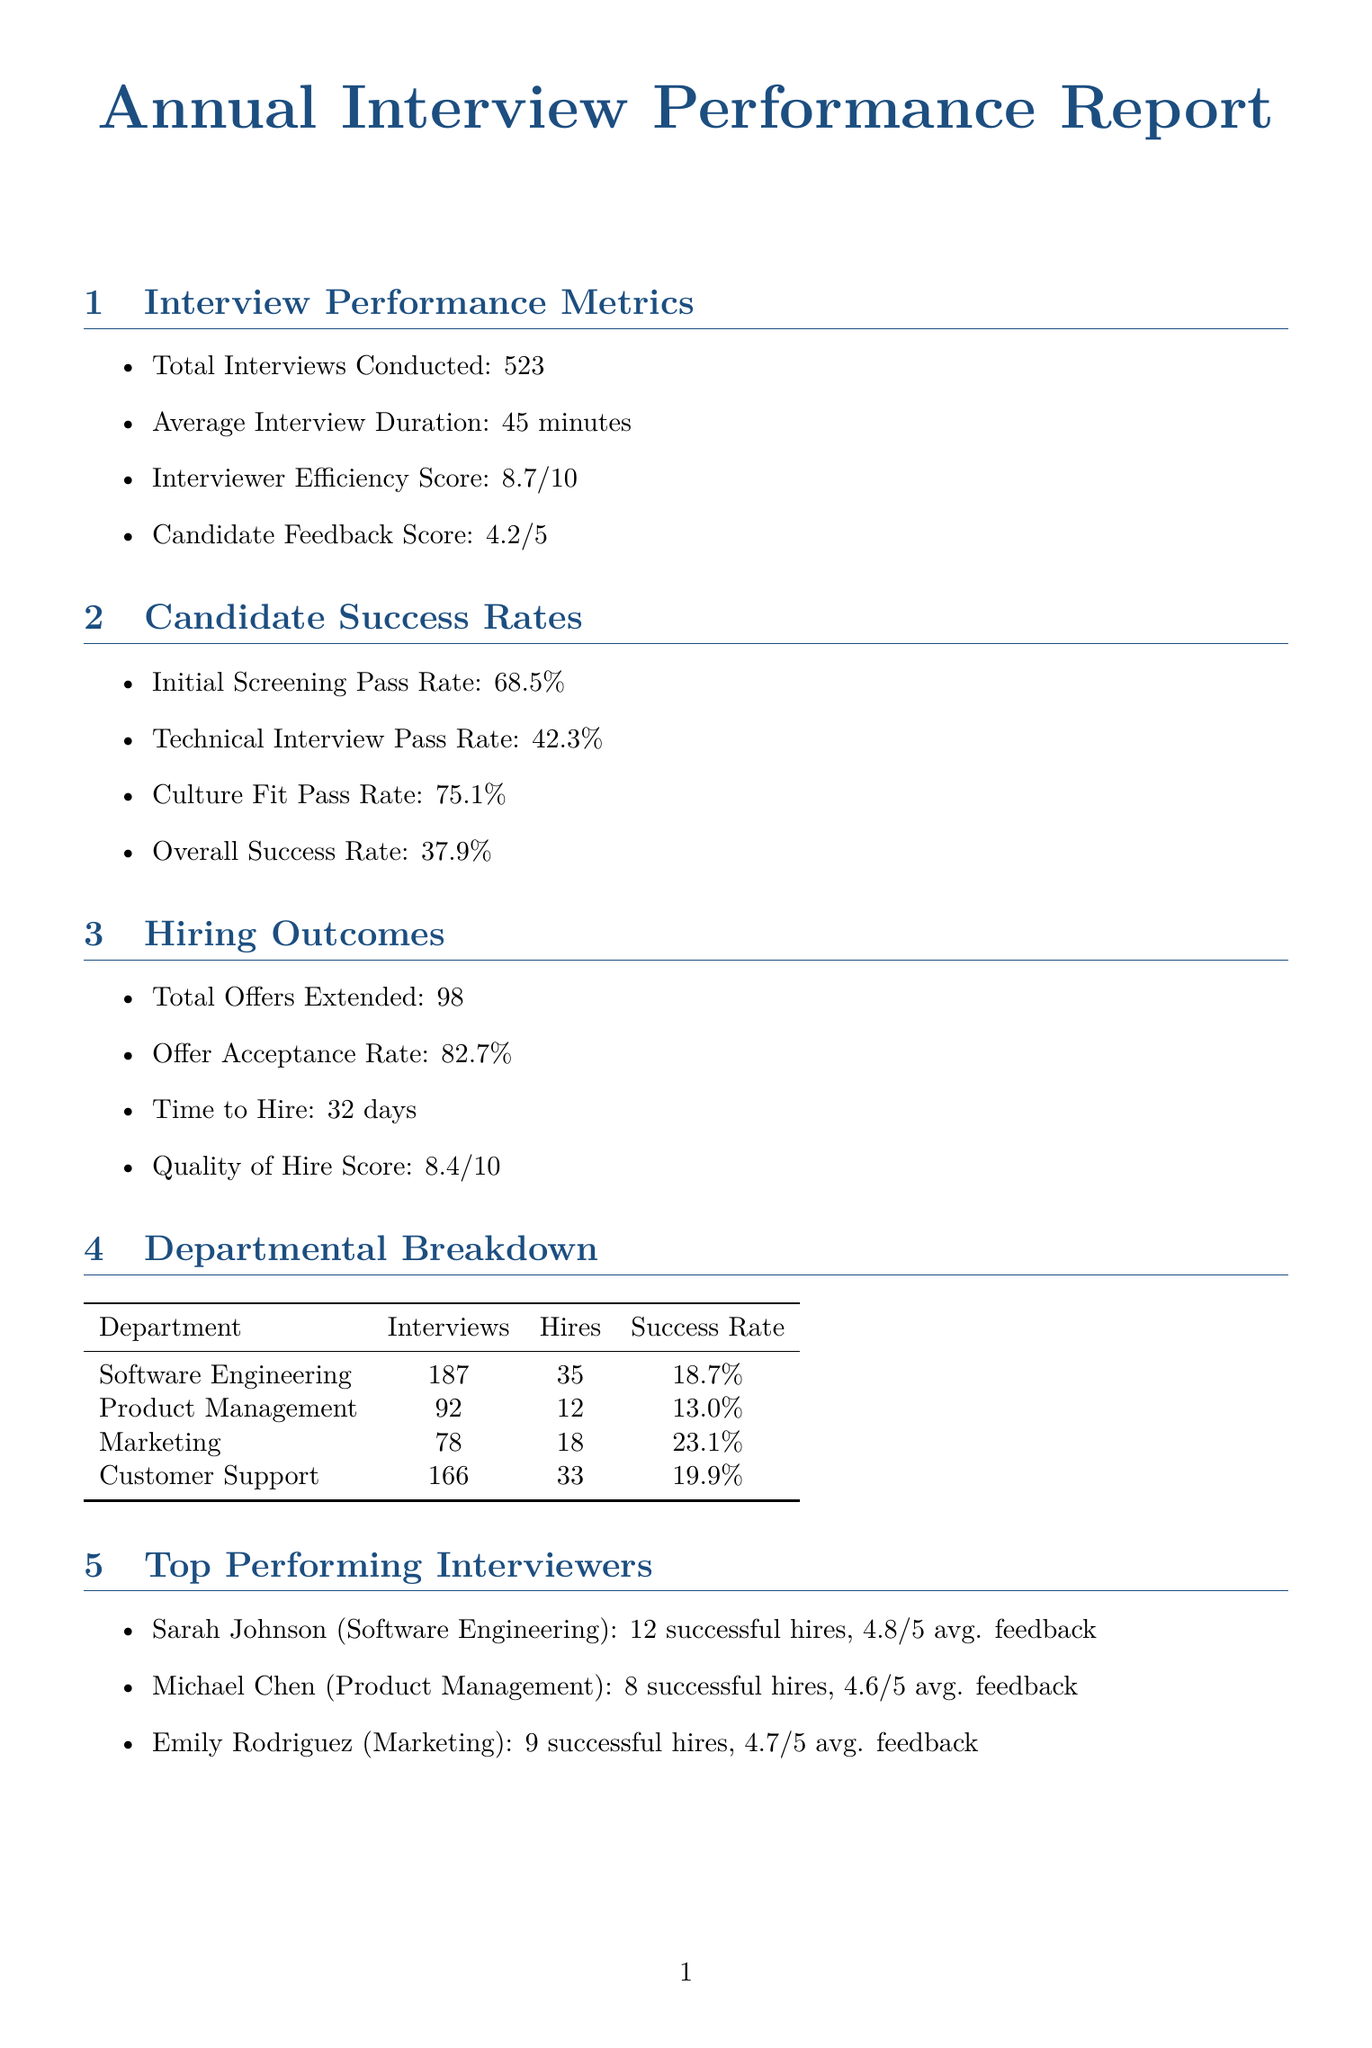What is the total number of interviews conducted? The total number of interviews conducted is explicitly stated in the document as 523.
Answer: 523 What is the average interview duration? The average interview duration is mentioned in the document as 45 minutes.
Answer: 45 minutes What is the overall success rate for candidates? The overall success rate for candidates is provided in the document as 37.9%.
Answer: 37.9% Who is the top performer in Software Engineering? The top performer in Software Engineering is identified in the document as Sarah Johnson.
Answer: Sarah Johnson What improvement was made to the technical interview pass rate? The document states that the technical interview pass rate improved by 15% compared to the previous year.
Answer: 15% What is the offer acceptance rate? The offer acceptance rate is indicated in the document as 82.7%.
Answer: 82.7% How many alumni were involved in interviews? The document specifies that 78 alumni were involved in interviews.
Answer: 78 What is the mentee success rate of the alumni mentorship program? The mentee success rate is reported in the document as 68.9%.
Answer: 68.9% What upcoming initiative involves gamified challenges? The document mentions introducing gamified coding challenges for software engineering candidates as an upcoming initiative.
Answer: Gamified coding challenges What area for improvement involves AI? The document highlights implementing AI-assisted resume screening to improve initial candidate selection as an area for improvement.
Answer: AI-assisted resume screening 